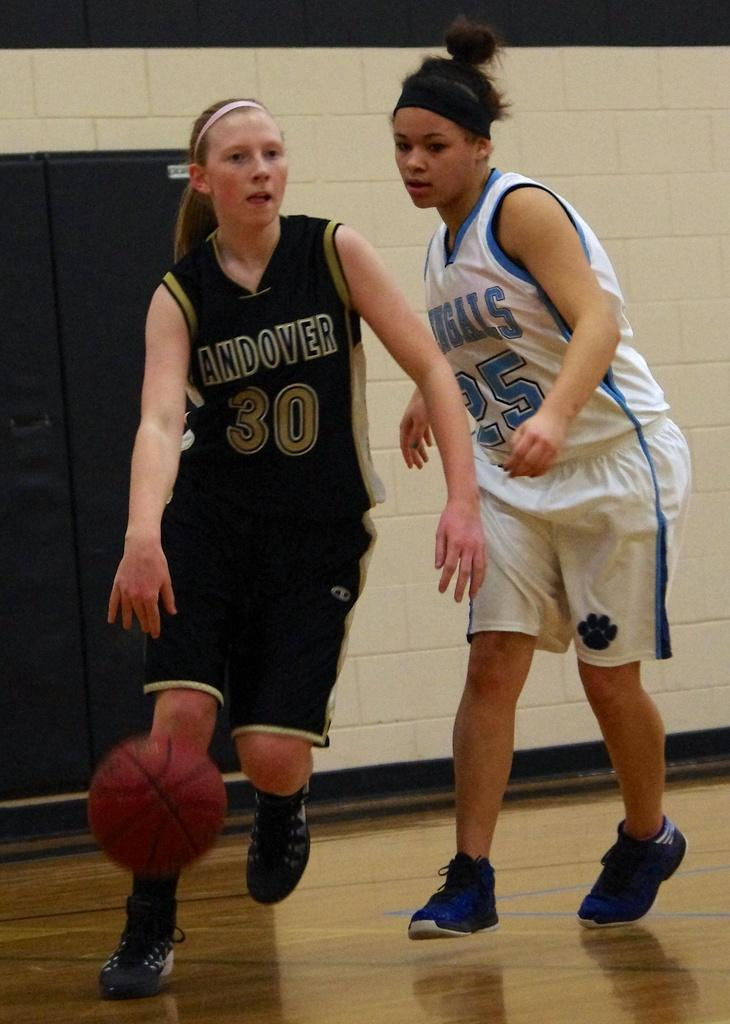<image>
Describe the image concisely. Basketball player with the number 30 on her jersey dribbling the ball. 